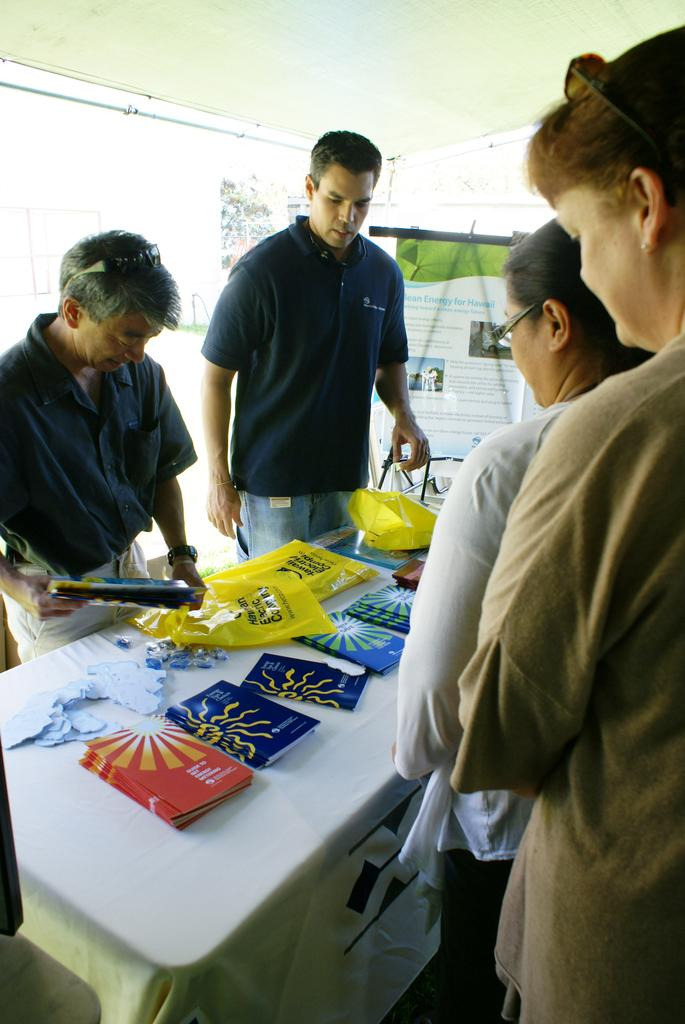How many people are in the image? There are four people in the image, two men and two women. What are the people doing in the image? The people are standing. What is present on the table in the image? There are carry bags and books on the table. What type of pipe can be seen in the image? There is no pipe present in the image. What game are the people playing in the image? The image does not depict any game being played; the people are simply standing. 